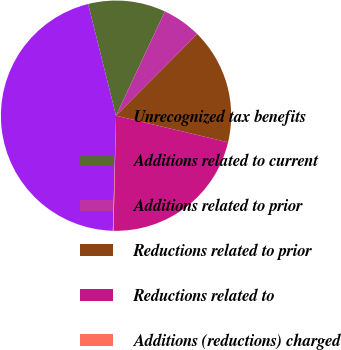Convert chart to OTSL. <chart><loc_0><loc_0><loc_500><loc_500><pie_chart><fcel>Unrecognized tax benefits<fcel>Additions related to current<fcel>Additions related to prior<fcel>Reductions related to prior<fcel>Reductions related to<fcel>Additions (reductions) charged<nl><fcel>45.66%<fcel>10.87%<fcel>5.48%<fcel>16.26%<fcel>21.64%<fcel>0.09%<nl></chart> 